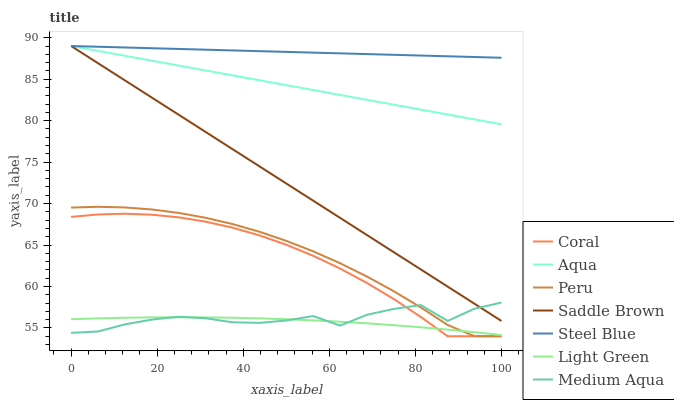Does Light Green have the minimum area under the curve?
Answer yes or no. Yes. Does Coral have the minimum area under the curve?
Answer yes or no. No. Does Coral have the maximum area under the curve?
Answer yes or no. No. Is Saddle Brown the smoothest?
Answer yes or no. Yes. Is Medium Aqua the roughest?
Answer yes or no. Yes. Is Coral the smoothest?
Answer yes or no. No. Is Coral the roughest?
Answer yes or no. No. Does Aqua have the lowest value?
Answer yes or no. No. Does Coral have the highest value?
Answer yes or no. No. Is Light Green less than Steel Blue?
Answer yes or no. Yes. Is Saddle Brown greater than Peru?
Answer yes or no. Yes. Does Light Green intersect Steel Blue?
Answer yes or no. No. 